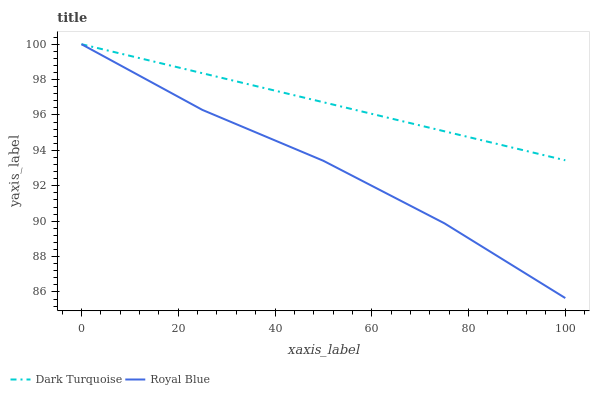Does Royal Blue have the maximum area under the curve?
Answer yes or no. No. Is Royal Blue the smoothest?
Answer yes or no. No. 